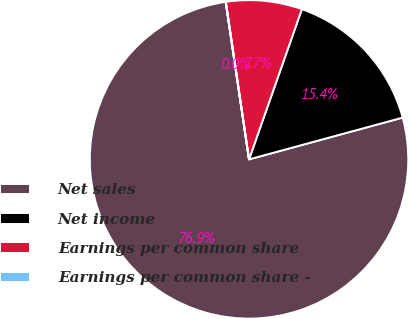Convert chart to OTSL. <chart><loc_0><loc_0><loc_500><loc_500><pie_chart><fcel>Net sales<fcel>Net income<fcel>Earnings per common share<fcel>Earnings per common share -<nl><fcel>76.87%<fcel>15.39%<fcel>7.71%<fcel>0.02%<nl></chart> 